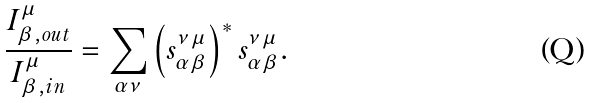<formula> <loc_0><loc_0><loc_500><loc_500>\frac { I _ { \beta , o u t } ^ { \mu } } { I _ { \beta , i n } ^ { \mu } } = \sum _ { \alpha \nu } \left ( s _ { \alpha \beta } ^ { \nu \mu } \right ) ^ { * } s _ { \alpha \beta } ^ { \nu \mu } .</formula> 